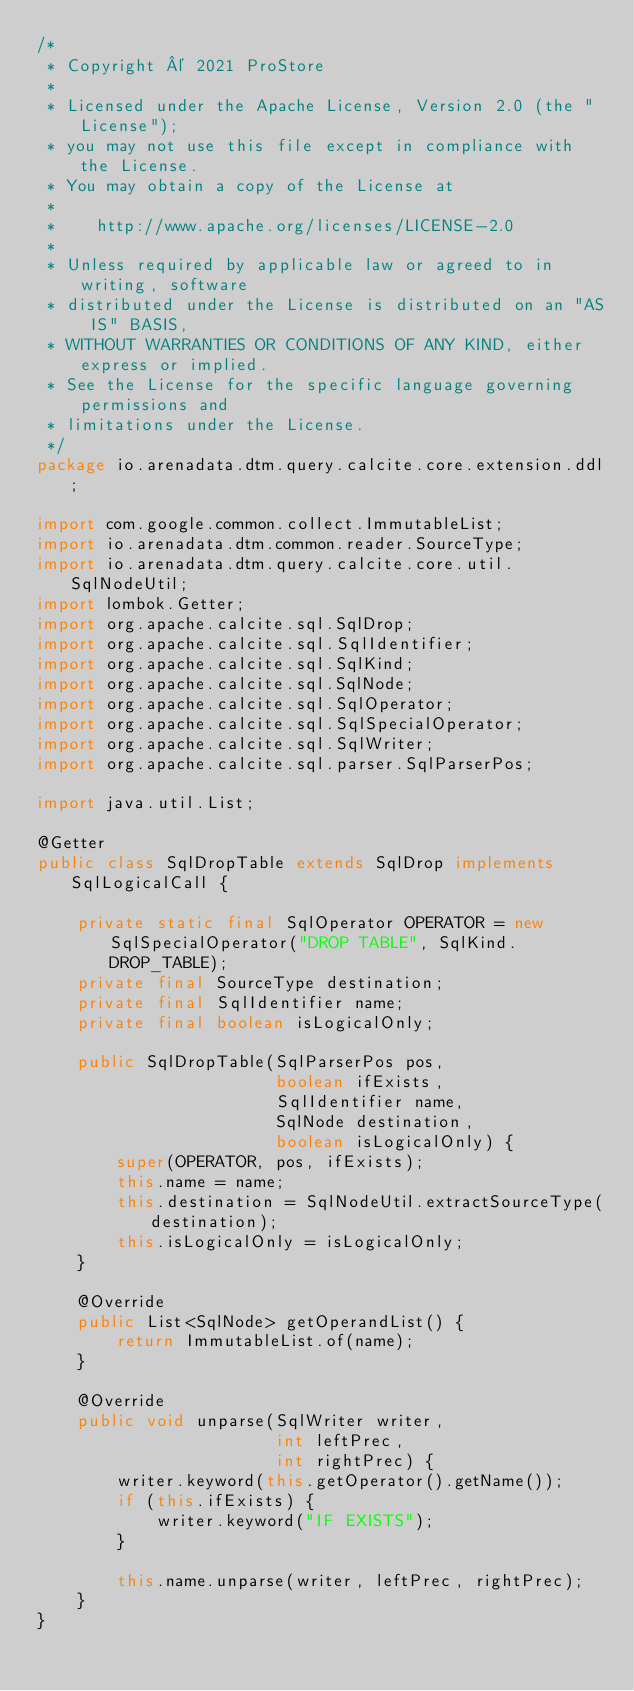Convert code to text. <code><loc_0><loc_0><loc_500><loc_500><_Java_>/*
 * Copyright © 2021 ProStore
 *
 * Licensed under the Apache License, Version 2.0 (the "License");
 * you may not use this file except in compliance with the License.
 * You may obtain a copy of the License at
 *
 *    http://www.apache.org/licenses/LICENSE-2.0
 *
 * Unless required by applicable law or agreed to in writing, software
 * distributed under the License is distributed on an "AS IS" BASIS,
 * WITHOUT WARRANTIES OR CONDITIONS OF ANY KIND, either express or implied.
 * See the License for the specific language governing permissions and
 * limitations under the License.
 */
package io.arenadata.dtm.query.calcite.core.extension.ddl;

import com.google.common.collect.ImmutableList;
import io.arenadata.dtm.common.reader.SourceType;
import io.arenadata.dtm.query.calcite.core.util.SqlNodeUtil;
import lombok.Getter;
import org.apache.calcite.sql.SqlDrop;
import org.apache.calcite.sql.SqlIdentifier;
import org.apache.calcite.sql.SqlKind;
import org.apache.calcite.sql.SqlNode;
import org.apache.calcite.sql.SqlOperator;
import org.apache.calcite.sql.SqlSpecialOperator;
import org.apache.calcite.sql.SqlWriter;
import org.apache.calcite.sql.parser.SqlParserPos;

import java.util.List;

@Getter
public class SqlDropTable extends SqlDrop implements SqlLogicalCall {

    private static final SqlOperator OPERATOR = new SqlSpecialOperator("DROP TABLE", SqlKind.DROP_TABLE);
    private final SourceType destination;
    private final SqlIdentifier name;
    private final boolean isLogicalOnly;

    public SqlDropTable(SqlParserPos pos,
                        boolean ifExists,
                        SqlIdentifier name,
                        SqlNode destination,
                        boolean isLogicalOnly) {
        super(OPERATOR, pos, ifExists);
        this.name = name;
        this.destination = SqlNodeUtil.extractSourceType(destination);
        this.isLogicalOnly = isLogicalOnly;
    }

    @Override
    public List<SqlNode> getOperandList() {
        return ImmutableList.of(name);
    }

    @Override
    public void unparse(SqlWriter writer,
                        int leftPrec,
                        int rightPrec) {
        writer.keyword(this.getOperator().getName());
        if (this.ifExists) {
            writer.keyword("IF EXISTS");
        }

        this.name.unparse(writer, leftPrec, rightPrec);
    }
}
</code> 